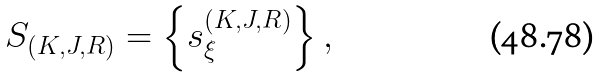Convert formula to latex. <formula><loc_0><loc_0><loc_500><loc_500>{ S } _ { ( K , J , R ) } = \left \{ s _ { \xi } ^ { ( K , J , R ) } \right \} ,</formula> 